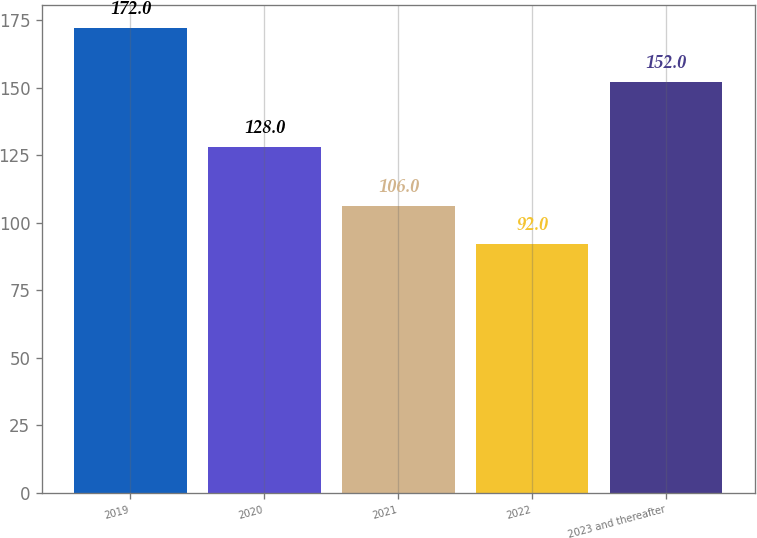<chart> <loc_0><loc_0><loc_500><loc_500><bar_chart><fcel>2019<fcel>2020<fcel>2021<fcel>2022<fcel>2023 and thereafter<nl><fcel>172<fcel>128<fcel>106<fcel>92<fcel>152<nl></chart> 